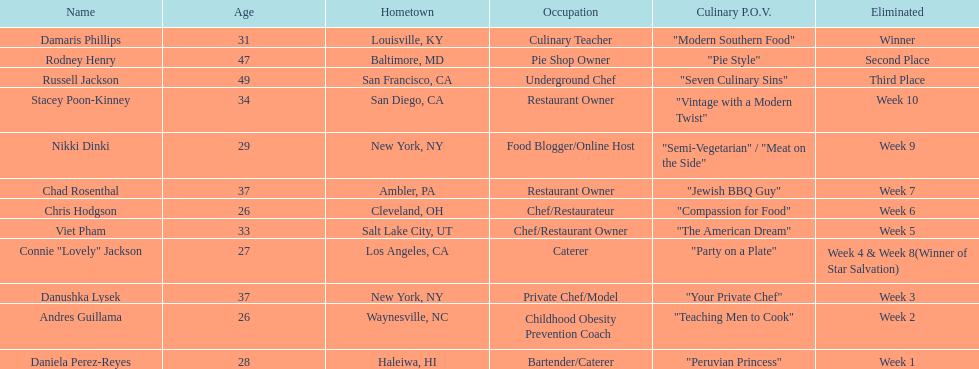Among the contestants, whose culinary viewpoint had a more detailed explanation than "vintage with a modern twist"? Nikki Dinki. 